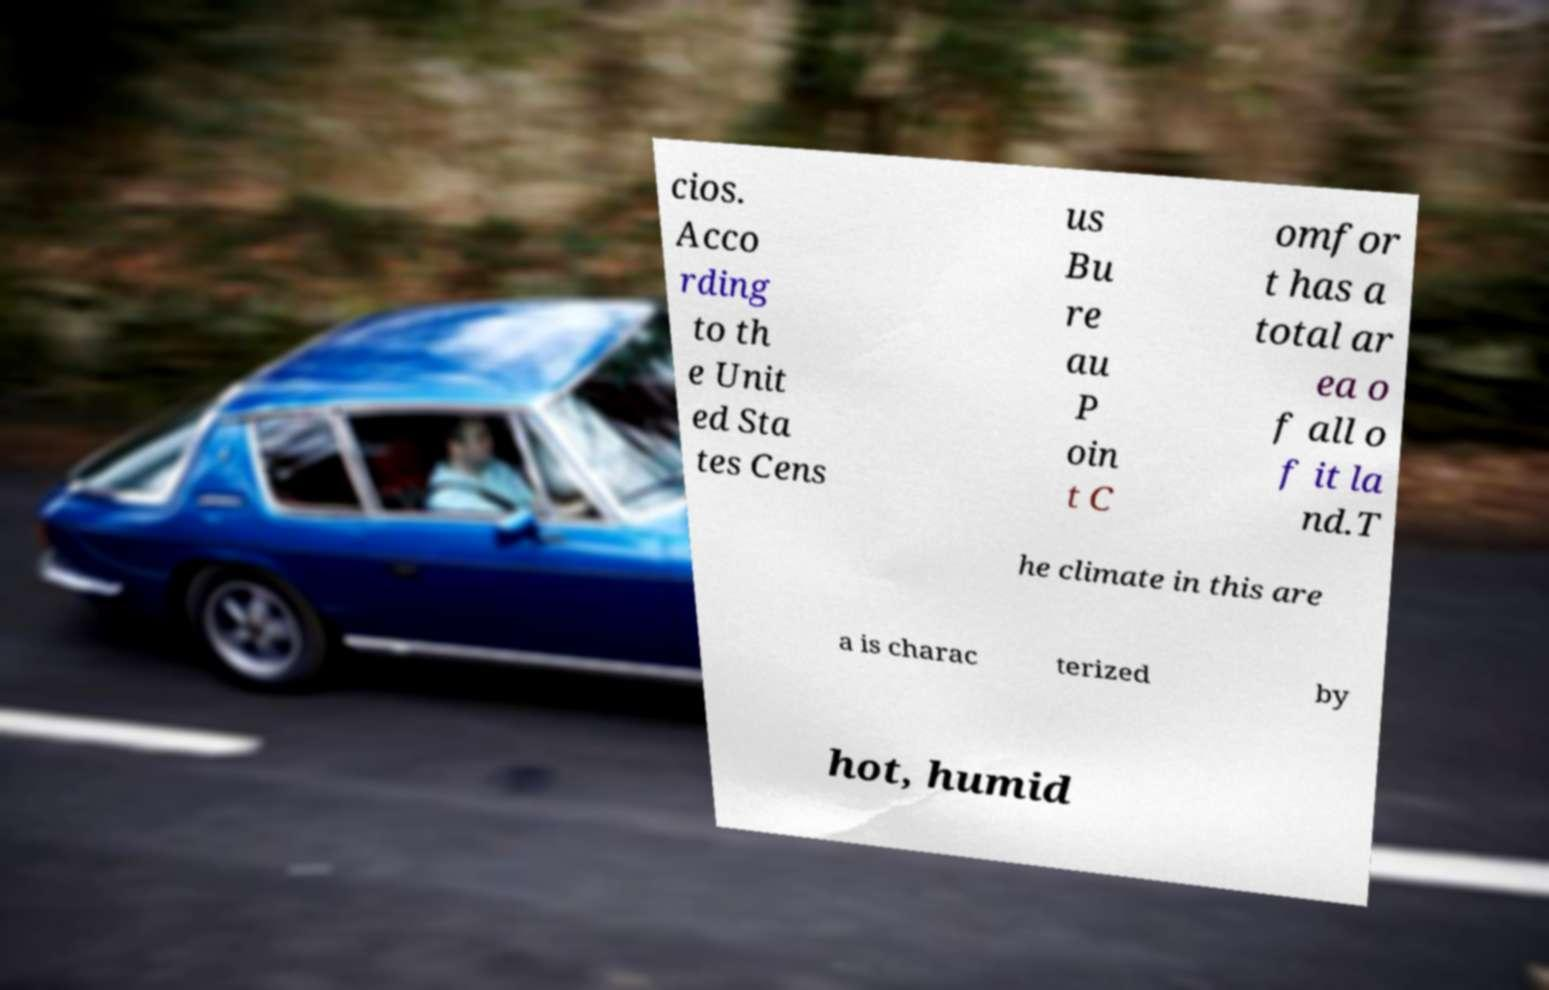Can you accurately transcribe the text from the provided image for me? cios. Acco rding to th e Unit ed Sta tes Cens us Bu re au P oin t C omfor t has a total ar ea o f all o f it la nd.T he climate in this are a is charac terized by hot, humid 